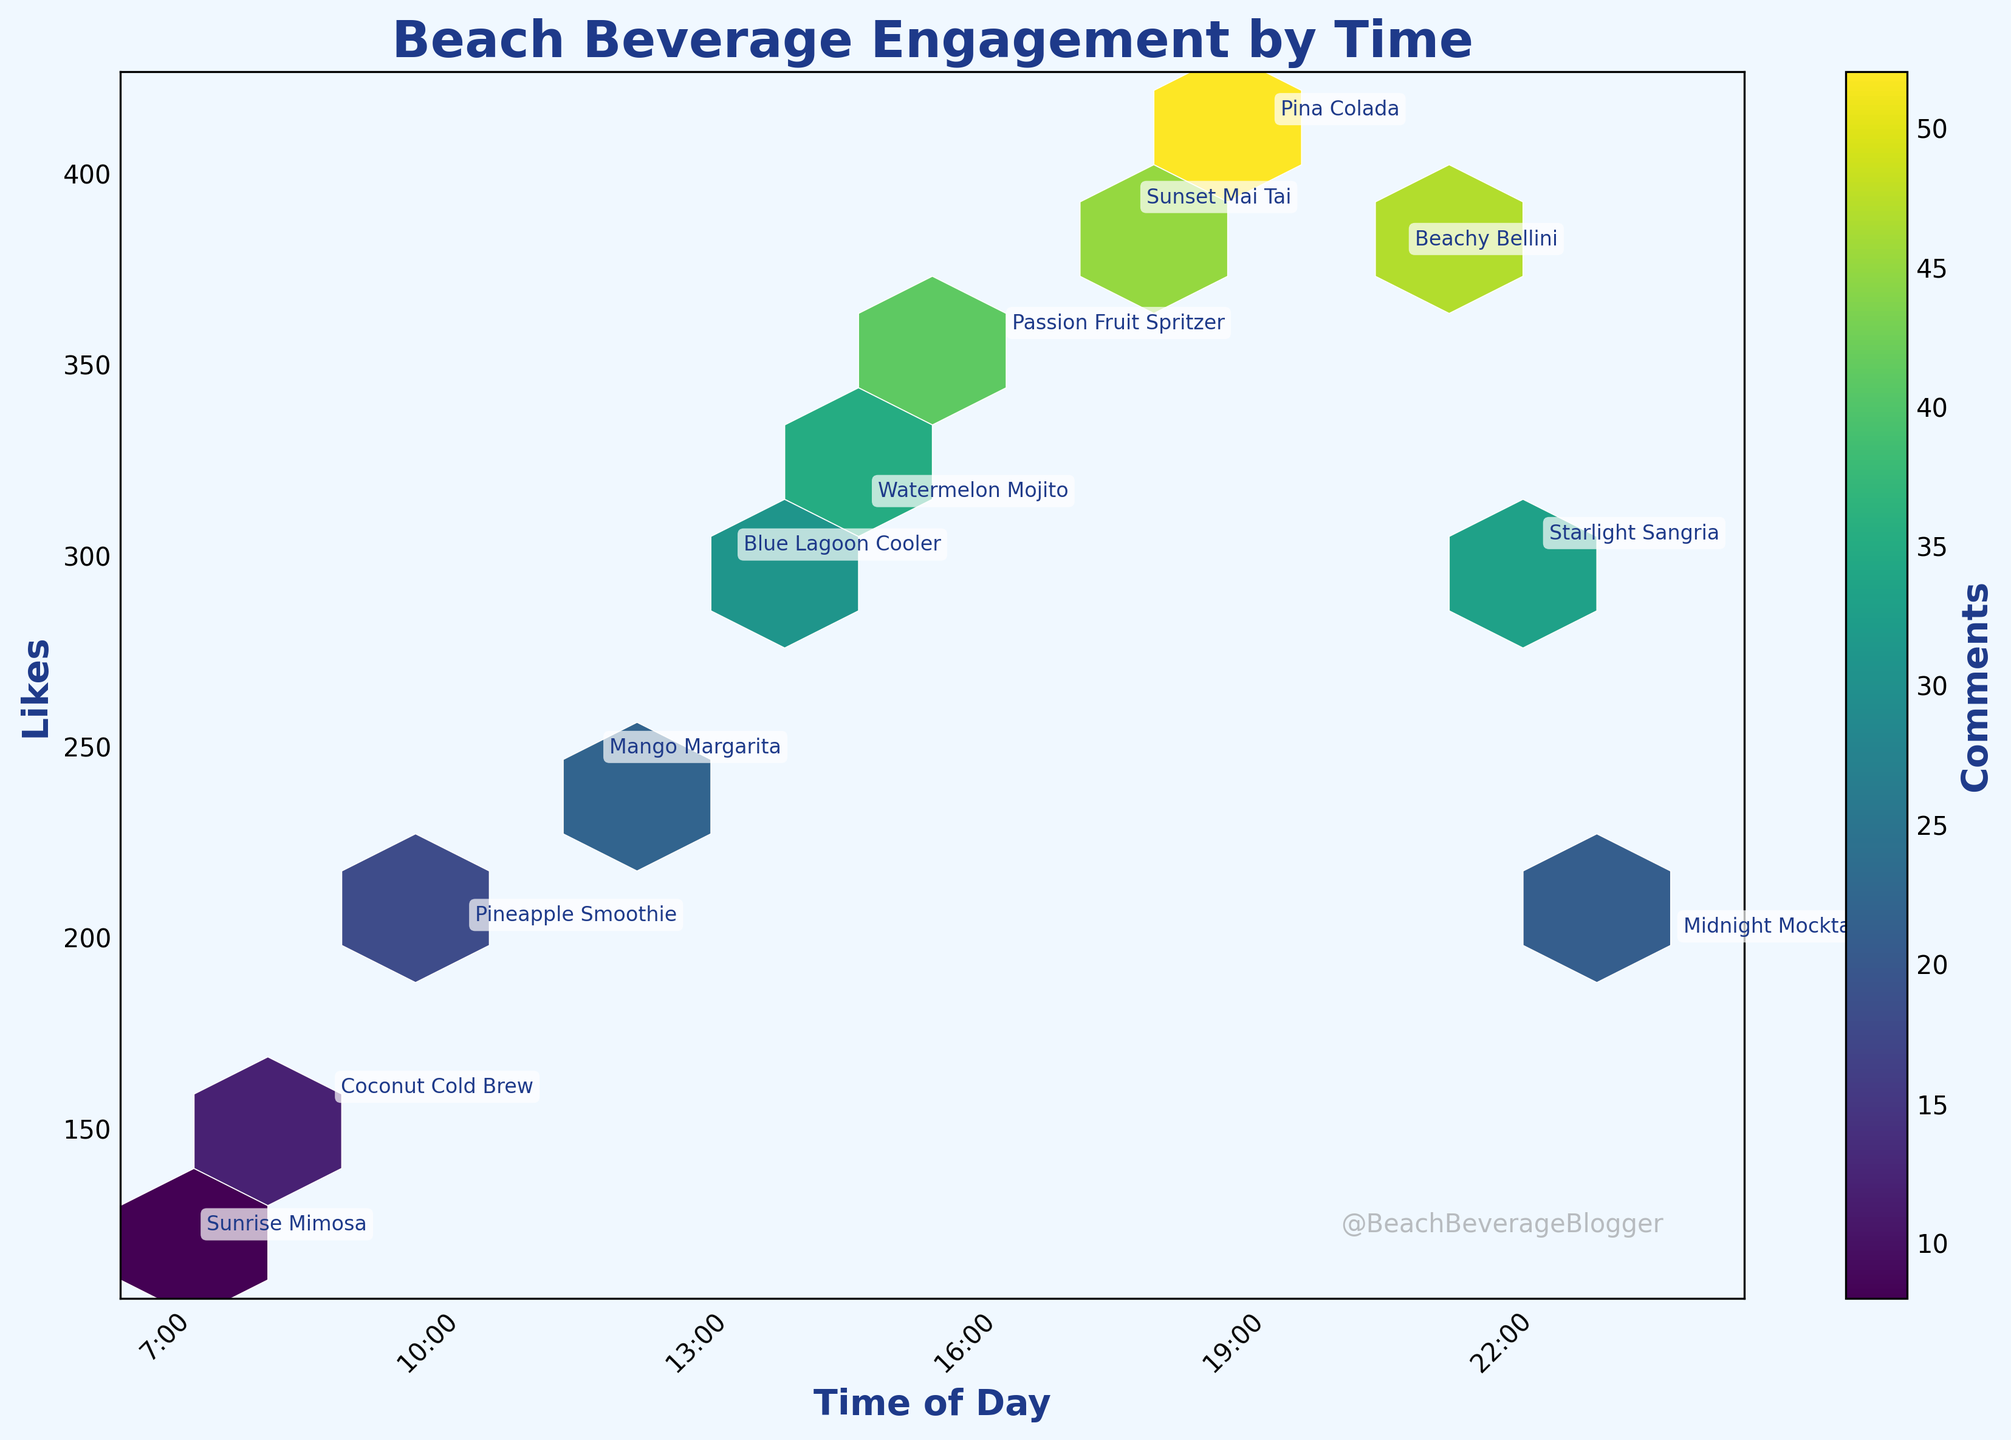What is the title of the plot? The title is provided at the top of the plot, usually in a bold and slightly larger font.
Answer: Beach Beverage Engagement by Time What are the axes labels for the plot? The axes labels are typically found along the respective x and y axes. The x-axis shows "Time of Day" and the y-axis shows "Likes".
Answer: Time of Day, Likes At what time of day does the "Sunset Mai Tai" post occur? Look at the annotations on the plot to locate "Sunset Mai Tai", then check the corresponding point on the x-axis, which represents the time of day.
Answer: 17:30 Which post received the most comments and how many comments did it receive? The color intensity (brightest color) in the hexbin plot corresponds to the highest number of comments. The brightest hexbin is for the "Pina Colada" post. Check the color bar to find the comment count.
Answer: Pina Colada, 52 Compare the number of likes between "Sunrise Mimosa" and "Midnight Mocktail" posts. Which one received more likes? Find the annotated points for "Sunrise Mimosa" and "Midnight Mocktail", then check the y-axis to compare the number of likes. "Sunrise Mimosa" received 120 likes, and "Midnight Mocktail" received 198 likes.
Answer: Midnight Mocktail What is the average number of likes for the posts made between 16:00 and 20:30? Find the "Likes" values for posts within the given time range, sum them up, and divide by the number of posts. (356 + 389 + 412 + 378) / 4 = 383.75
Answer: 383.75 What time of day had the least engagement in terms of comments? Locate the hexbin with the dullest color or least color intensity and check the time on the x-axis for that bin. The "Sunrise Mimosa" post at 7:00 had the least comments with 8.
Answer: 7:00 Which beach beverage received the most likes and at what time was it posted? Look for the highest point on the y-axis and find the associated annotation and x-axis value. The "Pina Colada" has 412 likes and was posted at 19:00.
Answer: Pina Colada, 19:00 How does the engagement in terms of comments differ between "Coconut Cold Brew" and "Starlight Sangria"? Find the points for "Coconut Cold Brew" and "Starlight Sangria" and refer to the color intensity. "Coconut Cold Brew" has 12 comments, and "Starlight Sangria" has 33 comments. The difference is 33 - 12 = 21.
Answer: 21 